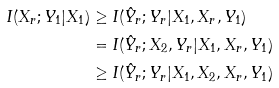<formula> <loc_0><loc_0><loc_500><loc_500>I ( X _ { r } ; Y _ { 1 } | X _ { 1 } ) & \geq I ( \hat { Y } _ { r } ; Y _ { r } | X _ { 1 } , X _ { r } , Y _ { 1 } ) \\ & = I ( \hat { Y } _ { r } ; X _ { 2 } , Y _ { r } | X _ { 1 } , X _ { r } , Y _ { 1 } ) \\ & \geq I ( \hat { Y } _ { r } ; Y _ { r } | X _ { 1 } , X _ { 2 } , X _ { r } , Y _ { 1 } )</formula> 